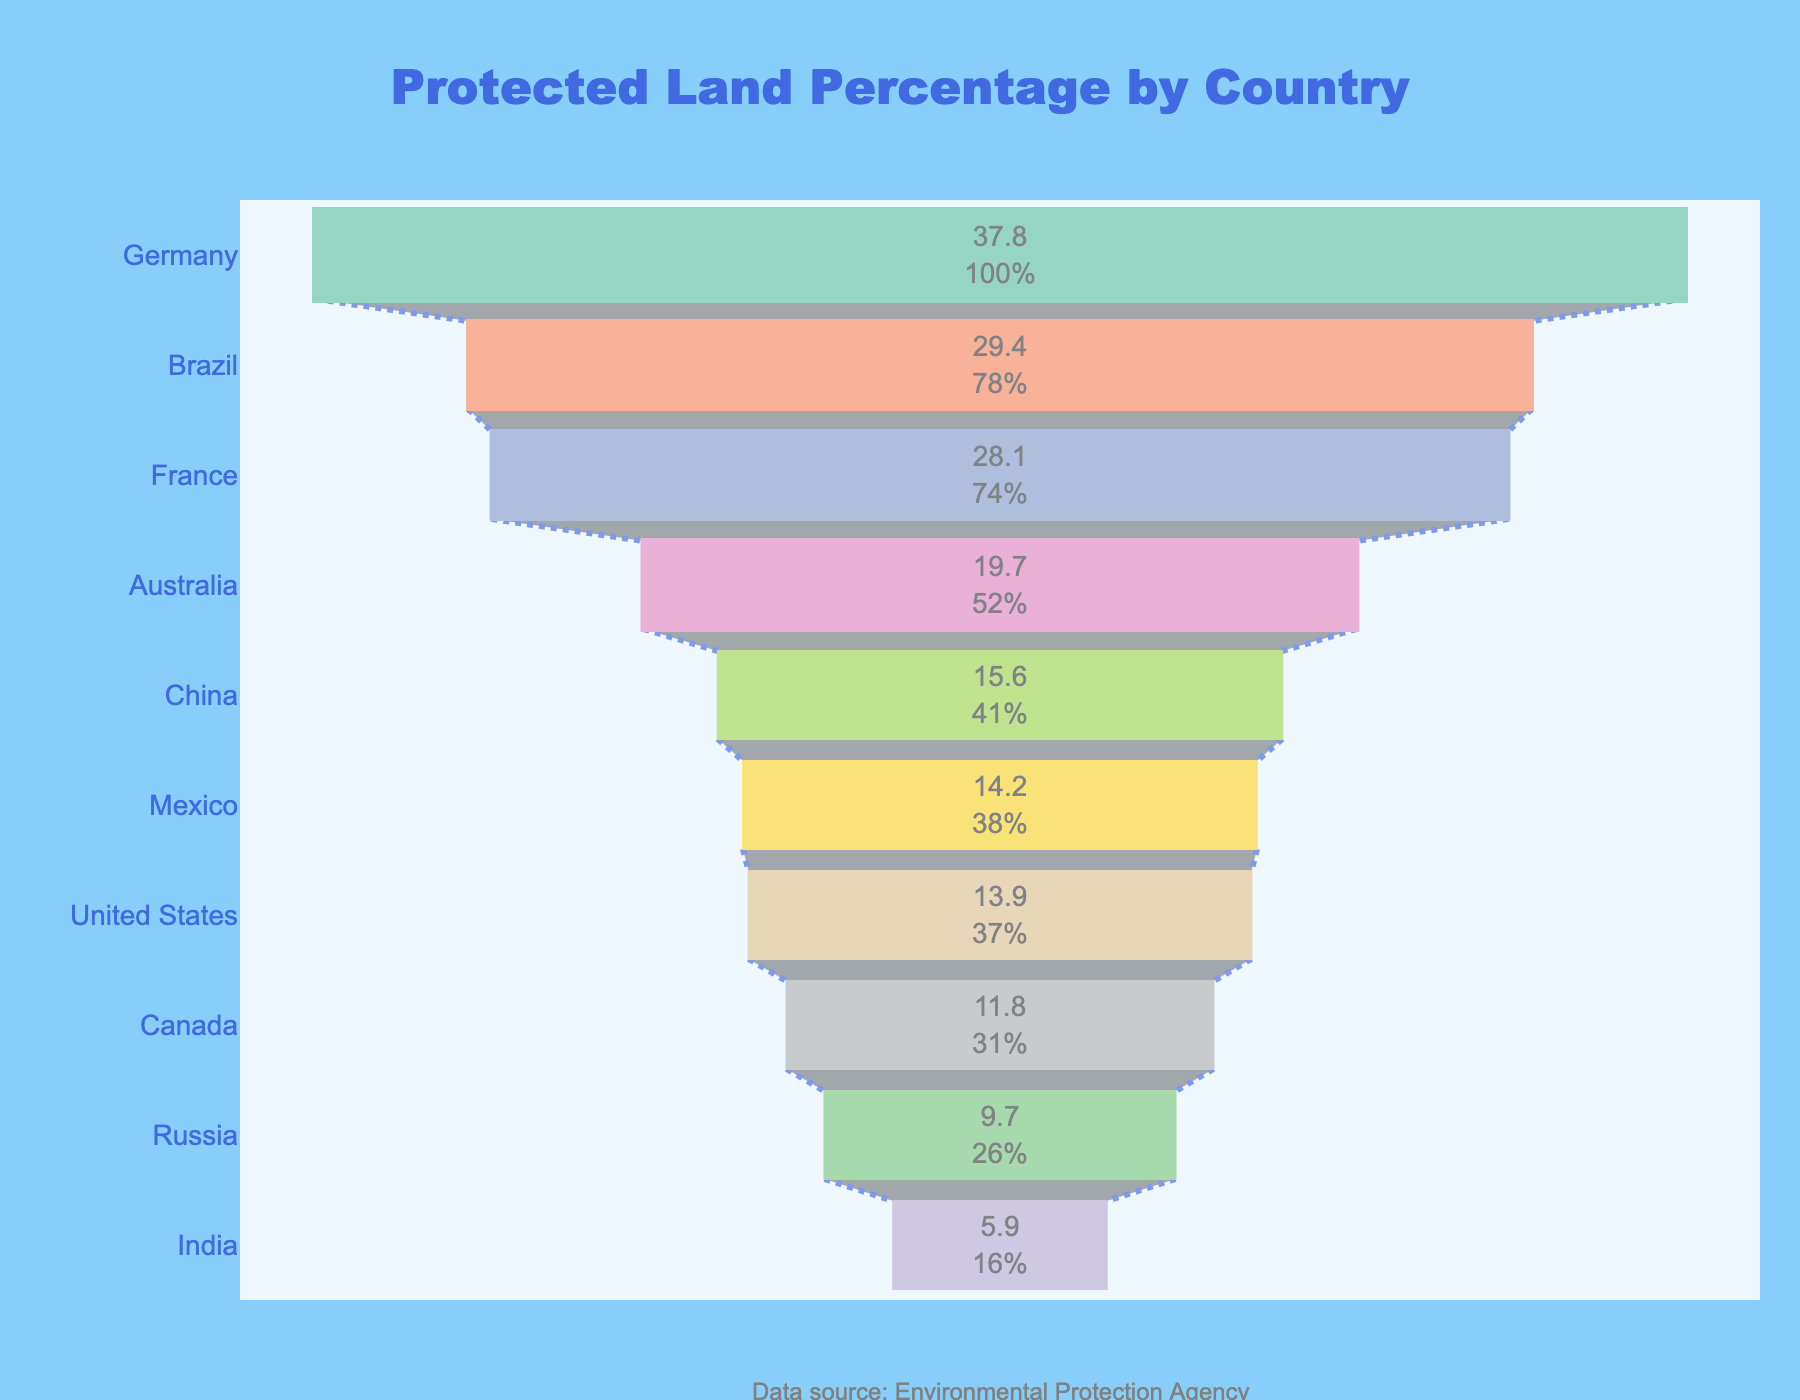What is the title of the funnel chart? The title is located at the top center of the funnel chart, written in larger, bold, and colorful text. It reads "Protected Land Percentage by Country."
Answer: Protected Land Percentage by Country Which country has the highest percentage of protected land? The country with the highest percentage of protected land is at the widest portion at the top of the funnel. In this case, it is Germany with 37.8%.
Answer: Germany What is the percentage of protected land in France? France is located second from the top in the funnel chart. The percentage next to France is 28.1%.
Answer: 28.1% How many countries have more than 20% of their land protected? By looking at the percentages listed next to each country in the funnel chart, count those countries with percentages above 20%. They are Germany, Brazil, and France, which totals three countries.
Answer: 3 Which country has slightly more protected land percentage, China or Mexico? Locate China and Mexico in the funnel chart and compare their percentages. China has 15.6% while Mexico has 14.2%, so China has a slightly higher percentage.
Answer: China What is the total percentage of protected land for Brazil and France combined? Brazil has a protected land percentage of 29.4% and France has 28.1%. Adding them together results in 29.4 + 28.1 = 57.5%.
Answer: 57.5% Which country has the lowest percentage of protected land? The country at the narrowest portion of the funnel, at the bottom, represents the lowest percentage. It is India with 5.9%.
Answer: India Compare the protected land percentages of Canada and Russia. Which is higher and by how much? Canada has 11.8% protected land and Russia has 9.7%. Canada has a higher percentage. The difference is 11.8 - 9.7 = 2.1%.
Answer: Canada, 2.1% What's the average protected land percentage among the ten countries? Sum the percentages of all ten countries and then divide by the number of countries (10). The total is 29.4 + 13.9 + 19.7 + 15.6 + 11.8 + 9.7 + 5.9 + 14.2 + 37.8 + 28.1 = 186.1%. The average is 186.1 / 10 = 18.61%.
Answer: 18.61% What is the median percentage of protected land among these countries? To find the median, list the percentages in order and identify the middle number. The ordered percentages are 5.9, 9.7, 11.8, 13.9, 14.2, 15.6, 19.7, 28.1, 29.4, 37.8. The middle values are 14.2 and 15.6. The median is the average of these two: (14.2 + 15.6) / 2 = 14.9%.
Answer: 14.9% 